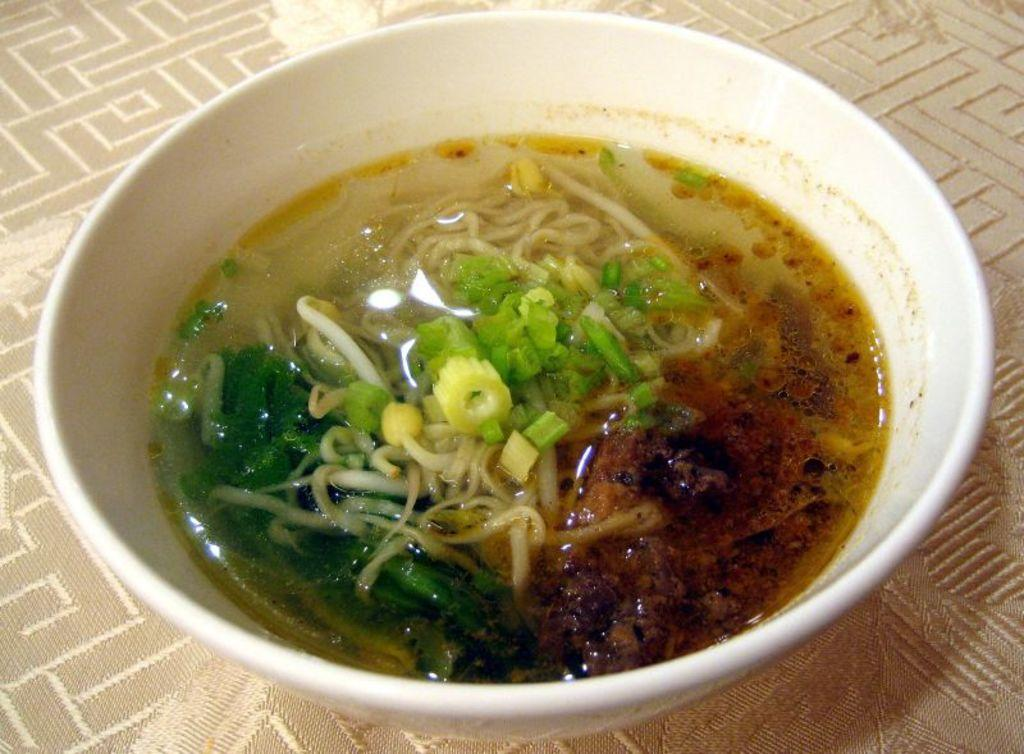What is present in the image? There is a bowl in the image. What is inside the bowl? There is a food item in the bowl. How many weeks does the alley take to complete? There is no alley present in the image, and therefore no such completion can be observed or measured. 